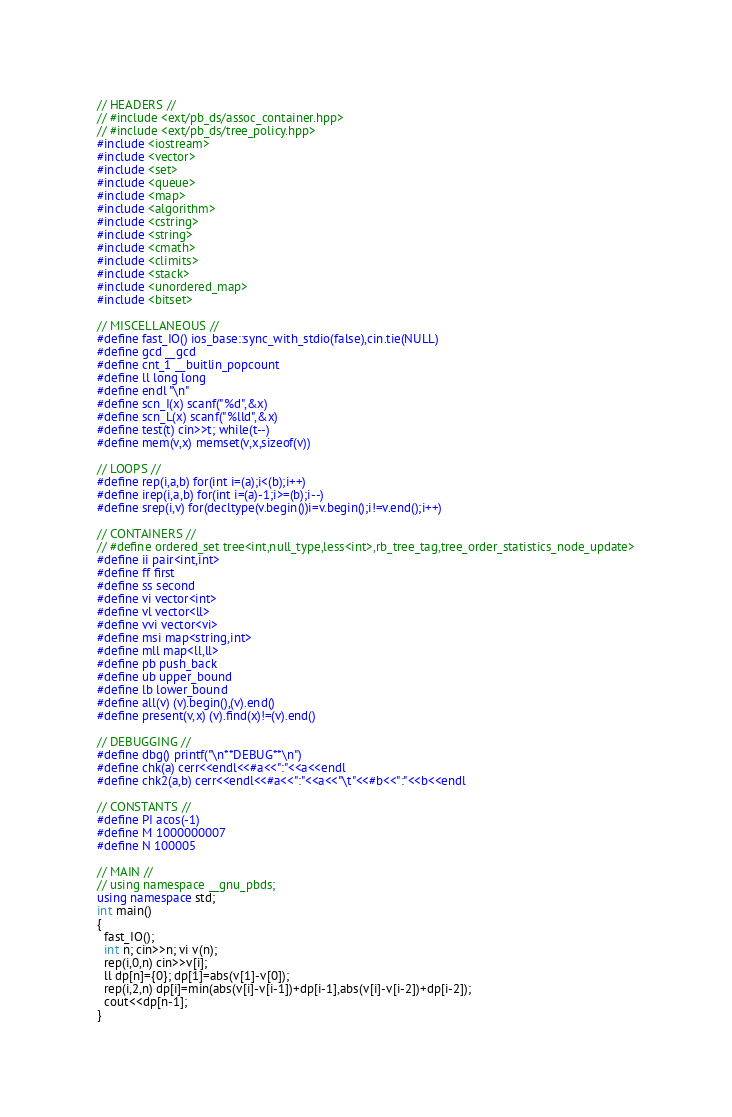Convert code to text. <code><loc_0><loc_0><loc_500><loc_500><_C++_>// HEADERS //
// #include <ext/pb_ds/assoc_container.hpp> 
// #include <ext/pb_ds/tree_policy.hpp> 
#include <iostream>
#include <vector>
#include <set>
#include <queue>
#include <map>
#include <algorithm>
#include <cstring>
#include <string>
#include <cmath>
#include <climits>
#include <stack>
#include <unordered_map>
#include <bitset>
 
// MISCELLANEOUS //
#define fast_IO() ios_base::sync_with_stdio(false),cin.tie(NULL)
#define gcd __gcd
#define cnt_1 __buitlin_popcount
#define ll long long
#define endl "\n"
#define scn_I(x) scanf("%d",&x)
#define scn_L(x) scanf("%lld",&x) 
#define test(t) cin>>t; while(t--)
#define mem(v,x) memset(v,x,sizeof(v))
 
// LOOPS //
#define rep(i,a,b) for(int i=(a);i<(b);i++)
#define irep(i,a,b) for(int i=(a)-1;i>=(b);i--)
#define srep(i,v) for(decltype(v.begin())i=v.begin();i!=v.end();i++)
 
// CONTAINERS //
// #define ordered_set tree<int,null_type,less<int>,rb_tree_tag,tree_order_statistics_node_update>
#define ii pair<int,int>
#define ff first
#define ss second
#define vi vector<int>
#define vl vector<ll>
#define vvi vector<vi>
#define msi map<string,int>
#define mll map<ll,ll>
#define pb push_back
#define ub upper_bound
#define lb lower_bound
#define all(v) (v).begin(),(v).end()
#define present(v,x) (v).find(x)!=(v).end()
 
// DEBUGGING //
#define dbg() printf("\n**DEBUG**\n") 
#define chk(a) cerr<<endl<<#a<<":"<<a<<endl
#define chk2(a,b) cerr<<endl<<#a<<":"<<a<<"\t"<<#b<<":"<<b<<endl
 
// CONSTANTS //
#define PI acos(-1)
#define M 1000000007
#define N 100005
 
// MAIN //
// using namespace __gnu_pbds; 
using namespace std;
int main()
{
  fast_IO();
  int n; cin>>n; vi v(n);
  rep(i,0,n) cin>>v[i];
  ll dp[n]={0}; dp[1]=abs(v[1]-v[0]);
  rep(i,2,n) dp[i]=min(abs(v[i]-v[i-1])+dp[i-1],abs(v[i]-v[i-2])+dp[i-2]);
  cout<<dp[n-1];
}</code> 